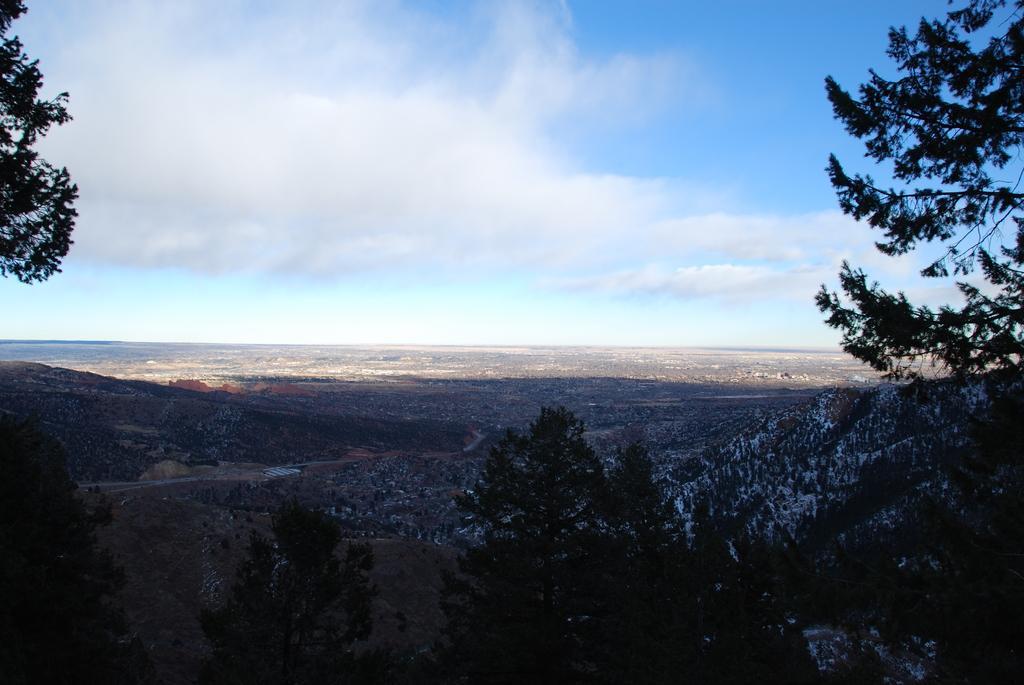Could you give a brief overview of what you see in this image? In this picture we can see trees in the front, there is the sky at the top of the picture. 